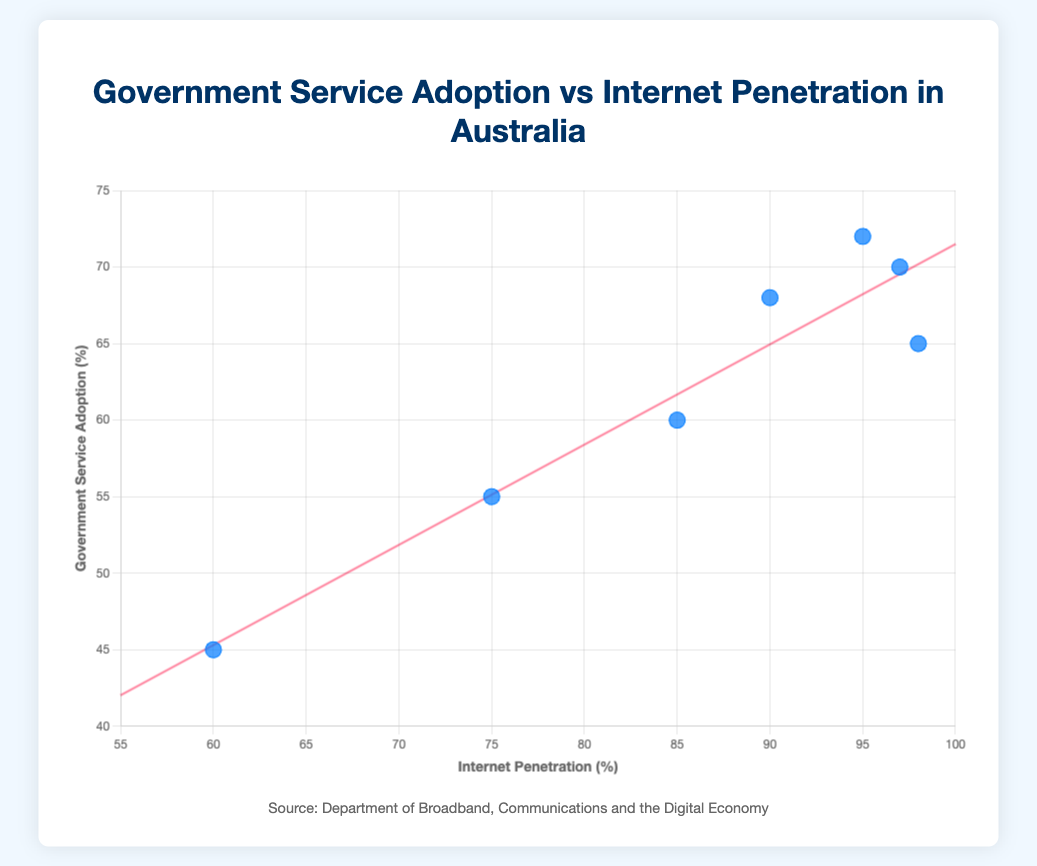What's the title of the plot? The title of the plot is displayed at the top of the figure, providing a summary of what the plot represents.
Answer: Government Service Adoption vs Internet Penetration in Australia What age group has the highest internet penetration rate? To find the age group with the highest internet penetration rate, look at the x-axis and identify the data point farthest to the right.
Answer: 18-24 Which age group has the lowest government service adoption rate? Check the y-axis and locate the data point that is at the lowest position on the vertical axis.
Answer: 75+ What's the range of internet penetration rates in the figure? Calculate the difference between the maximum and minimum values on the x-axis. The highest is 98%, and the lowest is 60%.
Answer: 38% How does the government service adoption rate correlate with internet penetration among the different age groups? By observing the scatter plot and the trend line, which points upwards, you can deduce that as internet penetration increases, government service adoption also tends to rise.
Answer: Positive correlation Which age groups fall above the trend line? Identify the data points above the red trend line, indicating higher-than-expected government service adoption rates for their internet penetration.
Answer: 25-34, 35-44 What is the exact percentage of government service adoption for the age group with 85% internet penetration? Locate the data point on the x-axis at 85% and look at its corresponding y-value.
Answer: 60% Calculate the average internet penetration rate of all age groups represented. Sum all the internet penetration rates and divide by the number of age groups: (98 + 97 + 95 + 90 + 85 + 75 + 60) / 7.
Answer: 85.71% What's the variance in government service adoption rates among the age groups? Calculate the mean government service adoption rate, then find the squared differences from the mean, and average those squared differences according to the formula for variance. Mean = (65 + 70 + 72 + 68 + 60 + 55 + 45) / 7 ≈ 62.14 and variance ≈ 67.98.
Answer: 67.98 Is there any age group with both internet penetration and government service adoption rates exactly the same? Compare the x and y values for each data point. None of the data points have identical x and y values for both criteria.
Answer: No 